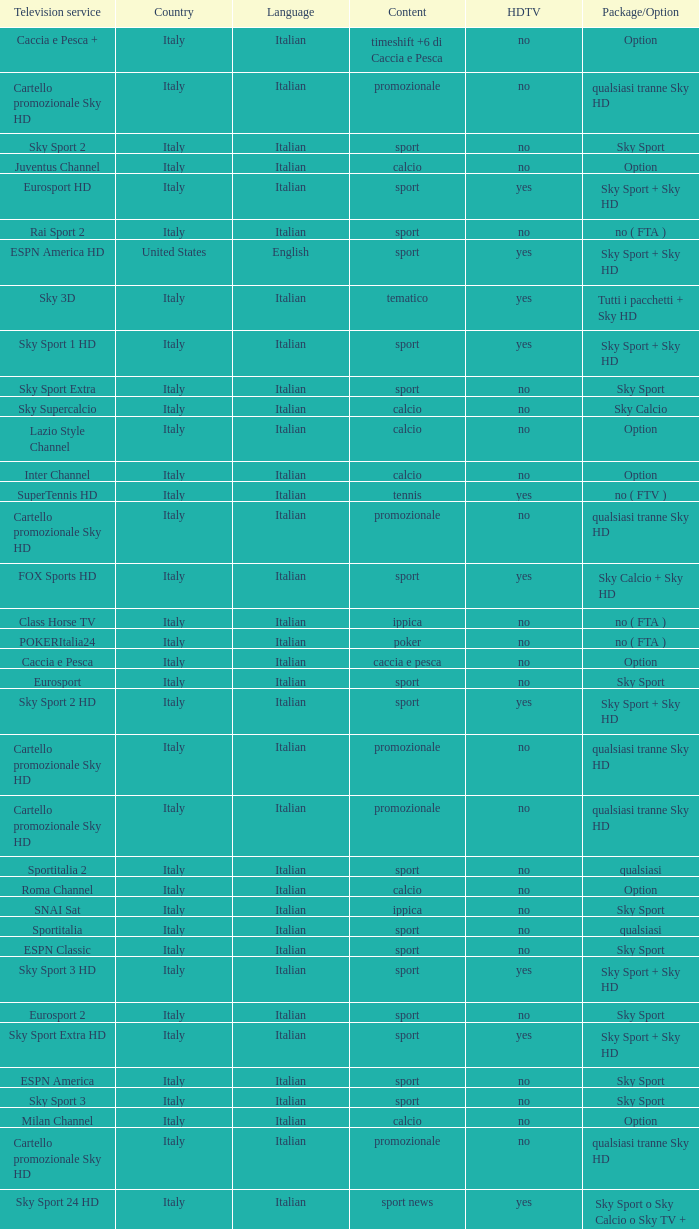What is Package/Option, when Content is Poker? No ( fta ). 